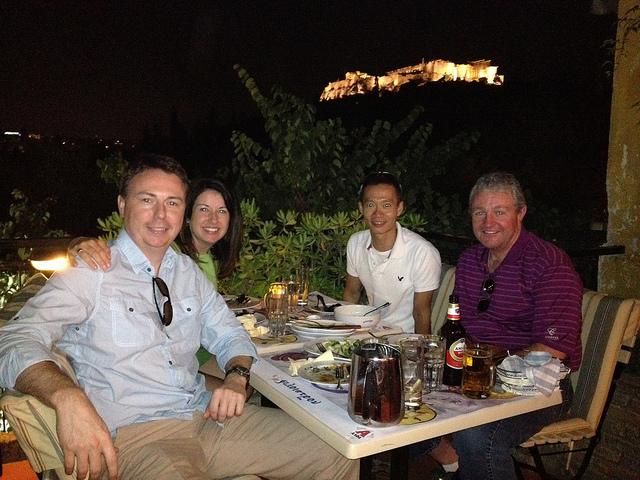Are all the people holding toys?
Give a very brief answer. No. What is the man drinking?
Keep it brief. Beer. How many pairs of sunglasses?
Be succinct. 2. What are these people eating?
Write a very short answer. Dinner. How many people are there?
Concise answer only. 4. How many people are shown?
Write a very short answer. 4. What are the men doing?
Short answer required. Smiling. What has this couple recently done?
Keep it brief. Gotten married. Are they enjoying each others company?
Give a very brief answer. Yes. What room is this?
Concise answer only. Patio. How many people are in the picture?
Be succinct. 4. How many people are sitting?
Write a very short answer. 4. What are they drinking?
Answer briefly. Beer. 